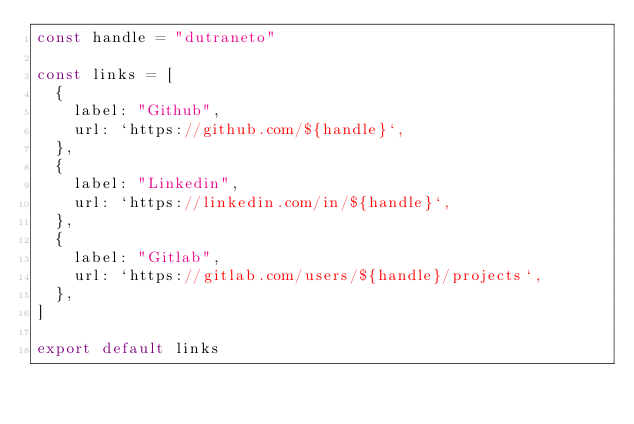Convert code to text. <code><loc_0><loc_0><loc_500><loc_500><_JavaScript_>const handle = "dutraneto"

const links = [
  {
    label: "Github",
    url: `https://github.com/${handle}`,
  },
  {
    label: "Linkedin",
    url: `https://linkedin.com/in/${handle}`,
  },
  {
    label: "Gitlab",
    url: `https://gitlab.com/users/${handle}/projects`,
  },
]

export default links
</code> 